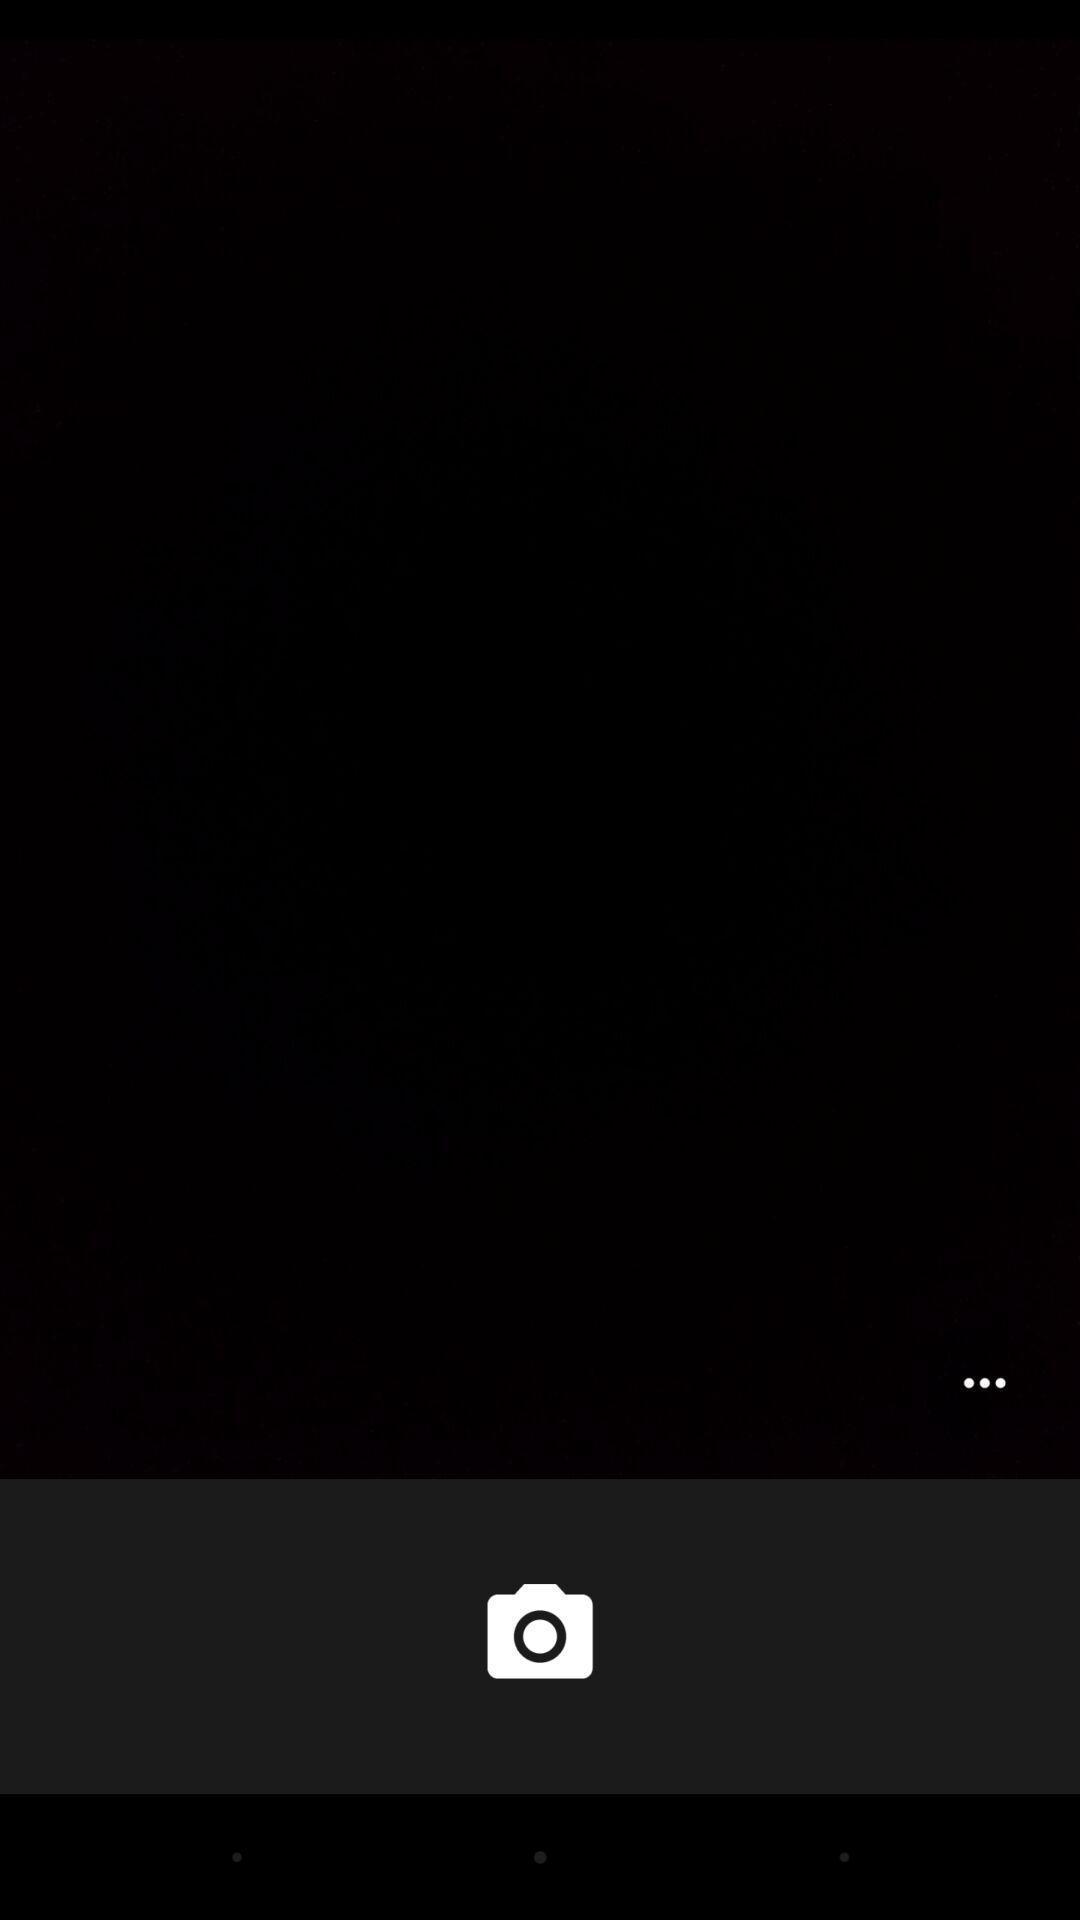What is the overall content of this screenshot? Screen displaying a blank page with camera icon. 